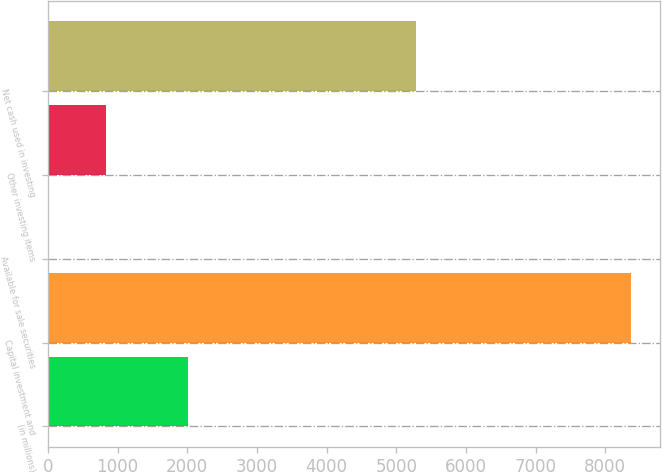Convert chart. <chart><loc_0><loc_0><loc_500><loc_500><bar_chart><fcel>(in millions)<fcel>Capital investment and<fcel>Available for sale securities<fcel>Other investing items<fcel>Net cash used in investing<nl><fcel>2015<fcel>8363<fcel>3<fcel>839<fcel>5277<nl></chart> 